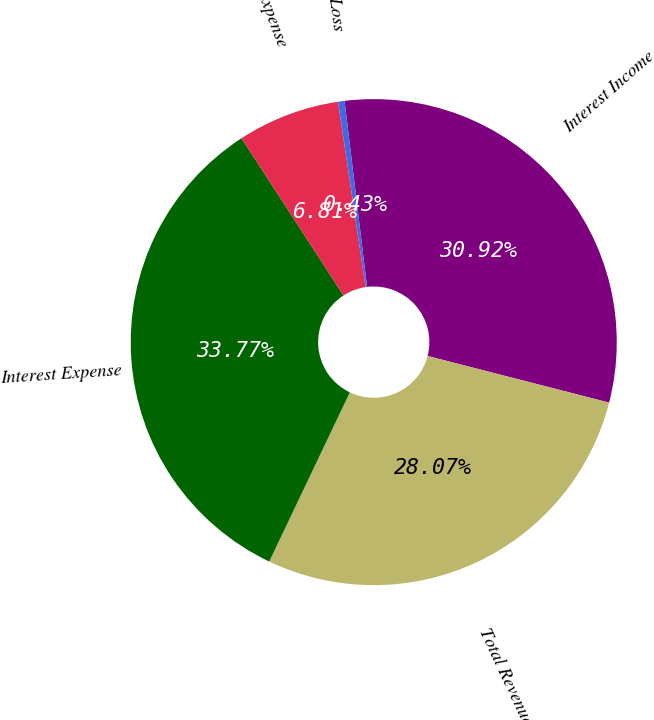Convert chart to OTSL. <chart><loc_0><loc_0><loc_500><loc_500><pie_chart><fcel>Interest Income<fcel>Total Revenues<fcel>Interest Expense<fcel>Other Expense<fcel>Pre-tax Loss<nl><fcel>30.92%<fcel>28.07%<fcel>33.77%<fcel>6.81%<fcel>0.43%<nl></chart> 